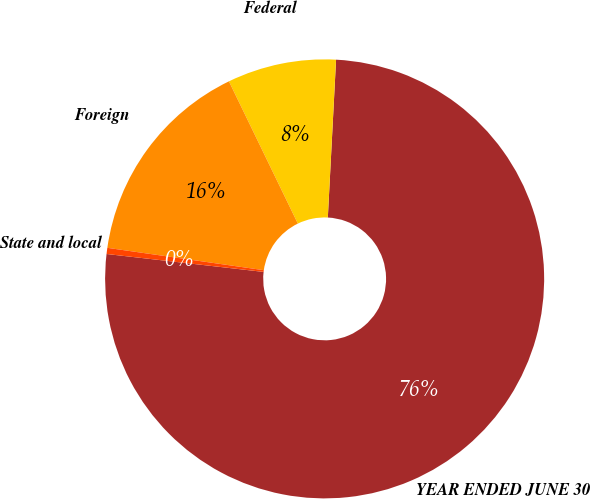Convert chart. <chart><loc_0><loc_0><loc_500><loc_500><pie_chart><fcel>YEAR ENDED JUNE 30<fcel>Federal<fcel>Foreign<fcel>State and local<nl><fcel>75.98%<fcel>8.01%<fcel>15.56%<fcel>0.45%<nl></chart> 